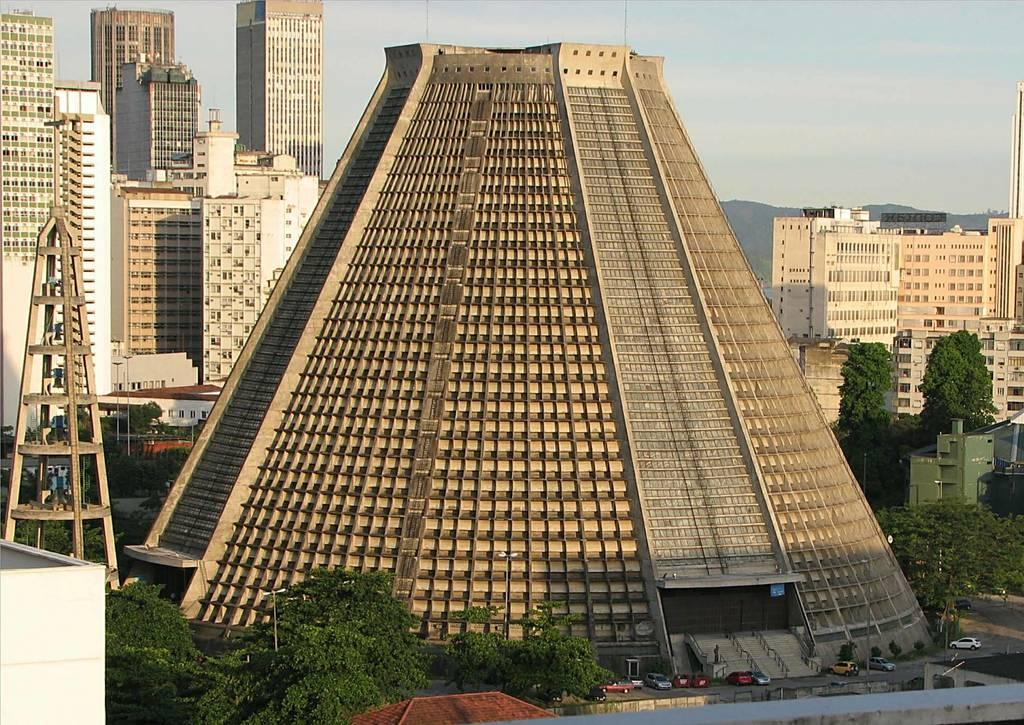What type of structures can be seen in the image? There are buildings in the image. What other natural elements are present in the image? There are trees in the image. What type of pathway is visible in the image? There is a road in the image. What mode of transportation can be seen in the image? There are vehicles in the image. What tall structure is present in the image? There is a tower in the image. What can be seen in the background of the image? The sky is visible in the background of the image. Where is the monkey sitting on the tower in the image? There is no monkey present in the image; it only features buildings, trees, a road, vehicles, a tower, and the sky. Can you tell me how many cobwebs are visible on the buildings in the image? There are no cobwebs visible on the buildings in the image. 